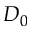Convert formula to latex. <formula><loc_0><loc_0><loc_500><loc_500>D _ { 0 }</formula> 